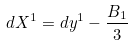<formula> <loc_0><loc_0><loc_500><loc_500>d X ^ { 1 } = d y ^ { 1 } - \frac { B _ { 1 } } { 3 }</formula> 